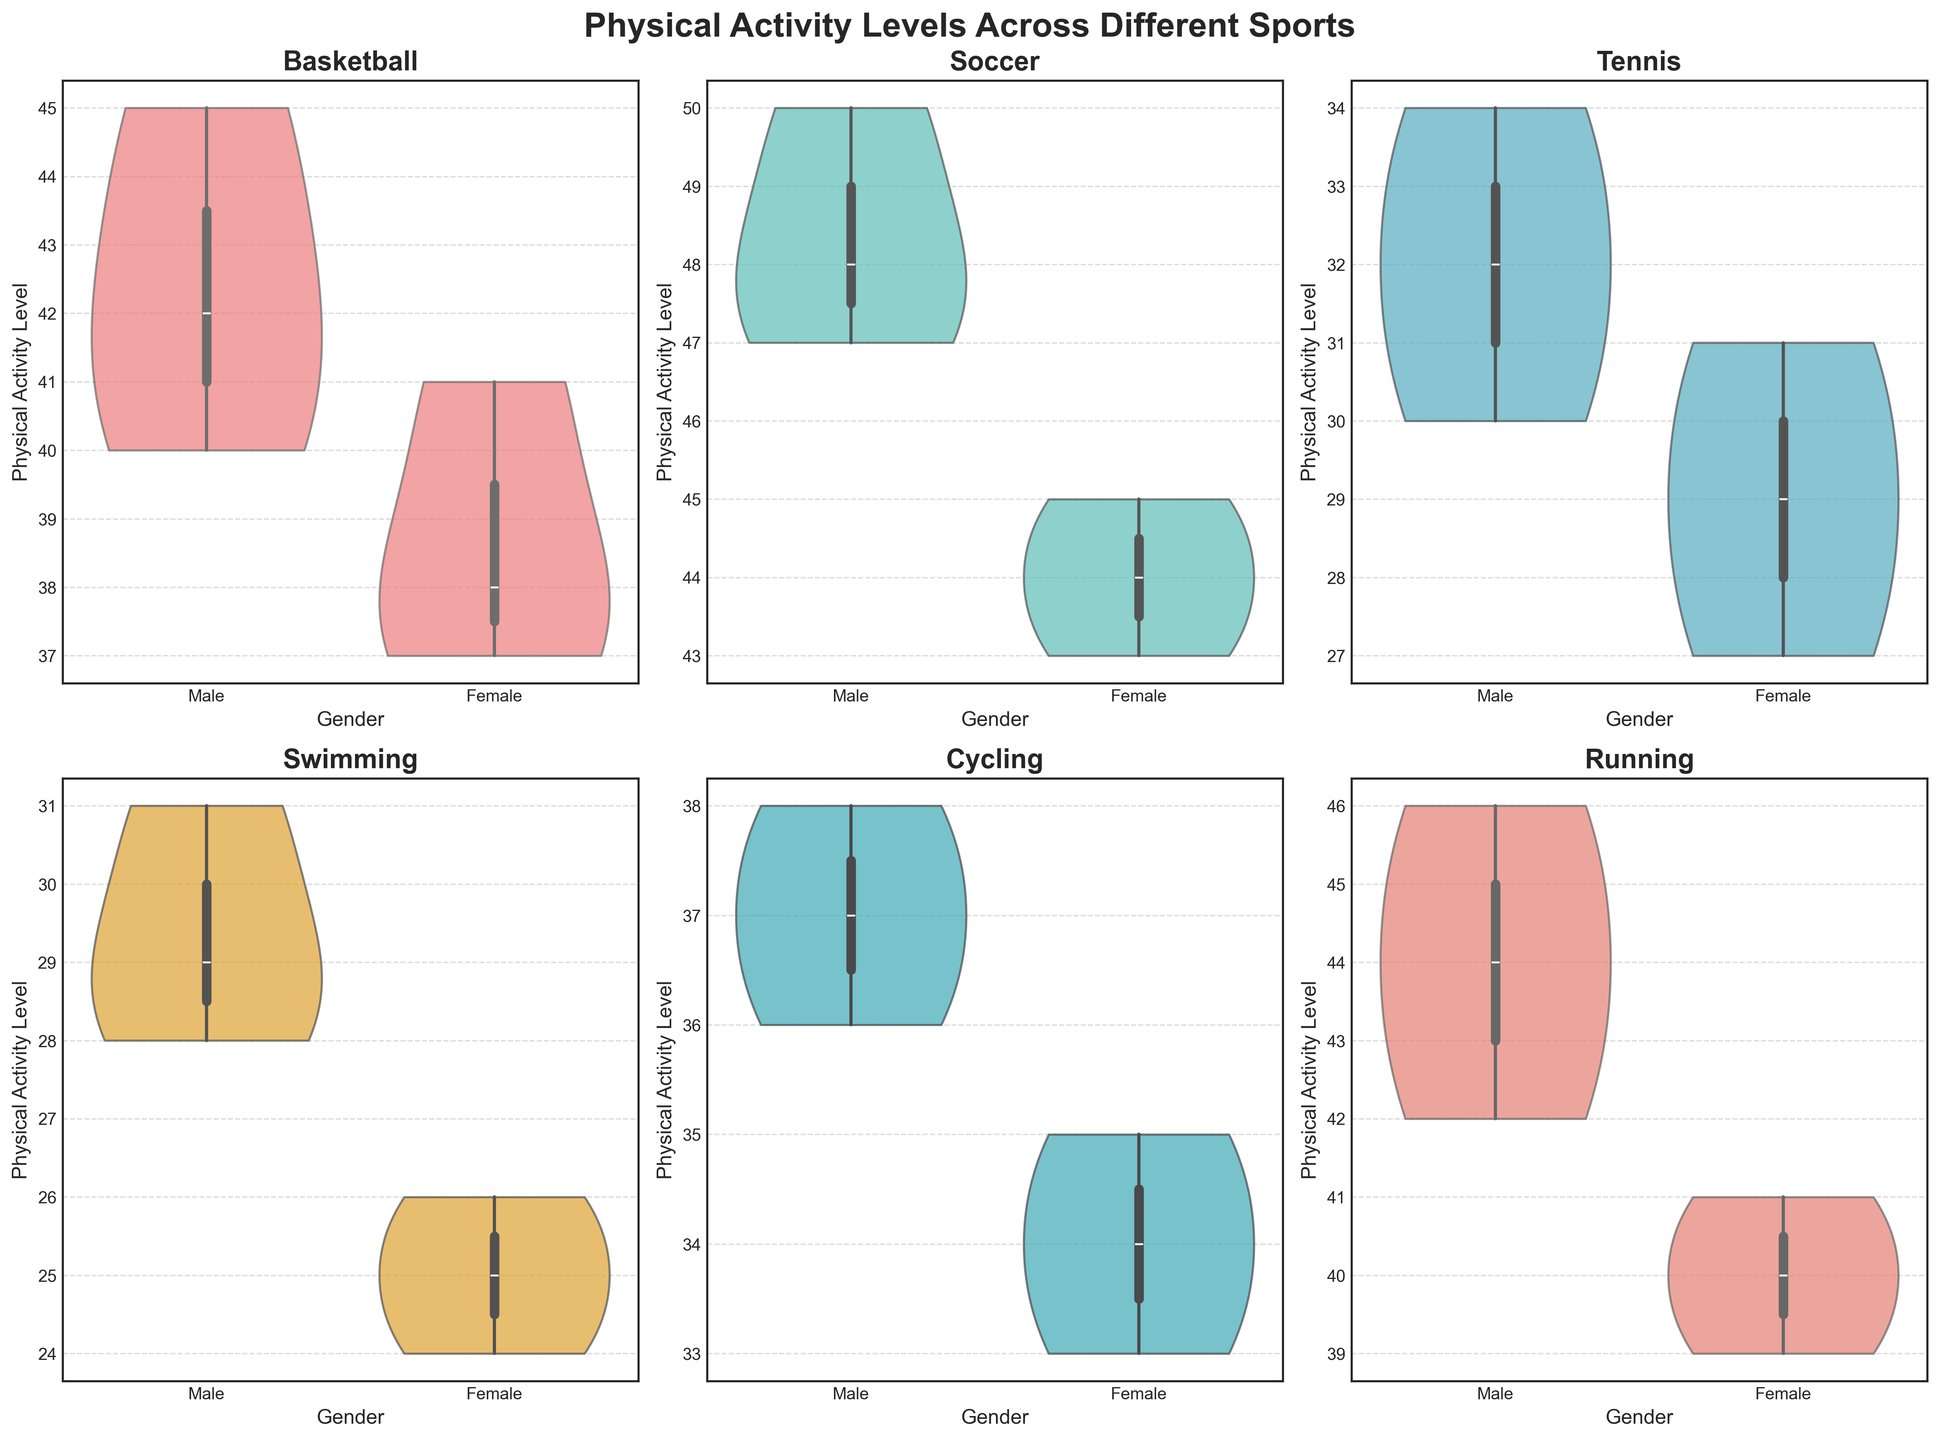What is the title of the figure? The title is displayed at the top of the figure in bold and larger font. It provides a summary of what the figure depicts.
Answer: Physical Activity Levels Across Different Sports Which sport has the highest median physical activity level for males? By observing the median line inside each violin plot, we can compare the values. Soccer has the highest median for males.
Answer: Soccer Are the physical activity levels higher for males or females in basketball? Viewing the basketball subplot, we compare the positions of the median lines within the violin plots for males and females. The median level for males is higher than that for females.
Answer: Males What are the sports listed in the figure? The titles of each subplot indicate the different sports being analyzed.
Answer: Basketball, Soccer, Tennis, Swimming, Cycling, Running Which gender generally shows a wider variability in physical activity levels in swimming? Observing the width of the violin plots for swimming, it is evident that the plot for males is wider, indicating greater variability.
Answer: Males In tennis, what is the range of physical activity levels for females? The range of a violin plot is from the bottom to the top of the colored area. For females in tennis, it ranges approximately from 27 to 31.
Answer: 27 to 31 Which sport has the smallest difference in median physical activity levels between males and females? Comparing the median lines across all subplots, tennis shows the smallest difference between males and females.
Answer: Tennis Is there a sport where female physical activity levels overlap completely with male physical activity levels? An overlap would mean the two violin plots for males and females completely cover each other. No such complete overlap appears in any sport.
Answer: No In cycling, how do the peaks of the physical activity levels differ between males and females? In the cycling subplot, the peaks of the violin plots for males and females can be compared; males peak higher than females.
Answer: Males peak higher What is the median physical activity level for males in running? The median line in the male violin plot for running can be identified. It is around 44 to 45.
Answer: Approximately 45 